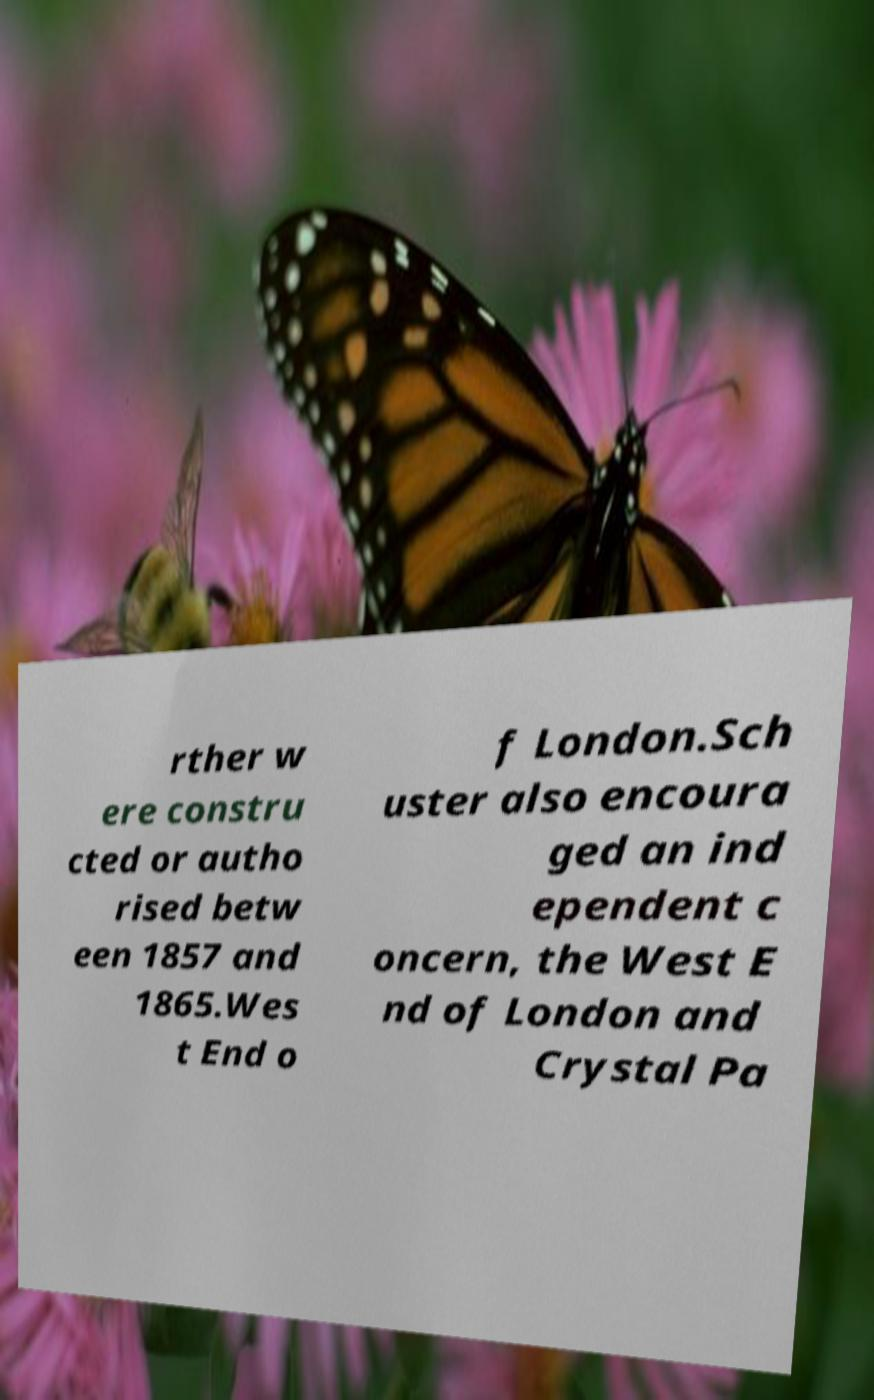Can you accurately transcribe the text from the provided image for me? rther w ere constru cted or autho rised betw een 1857 and 1865.Wes t End o f London.Sch uster also encoura ged an ind ependent c oncern, the West E nd of London and Crystal Pa 